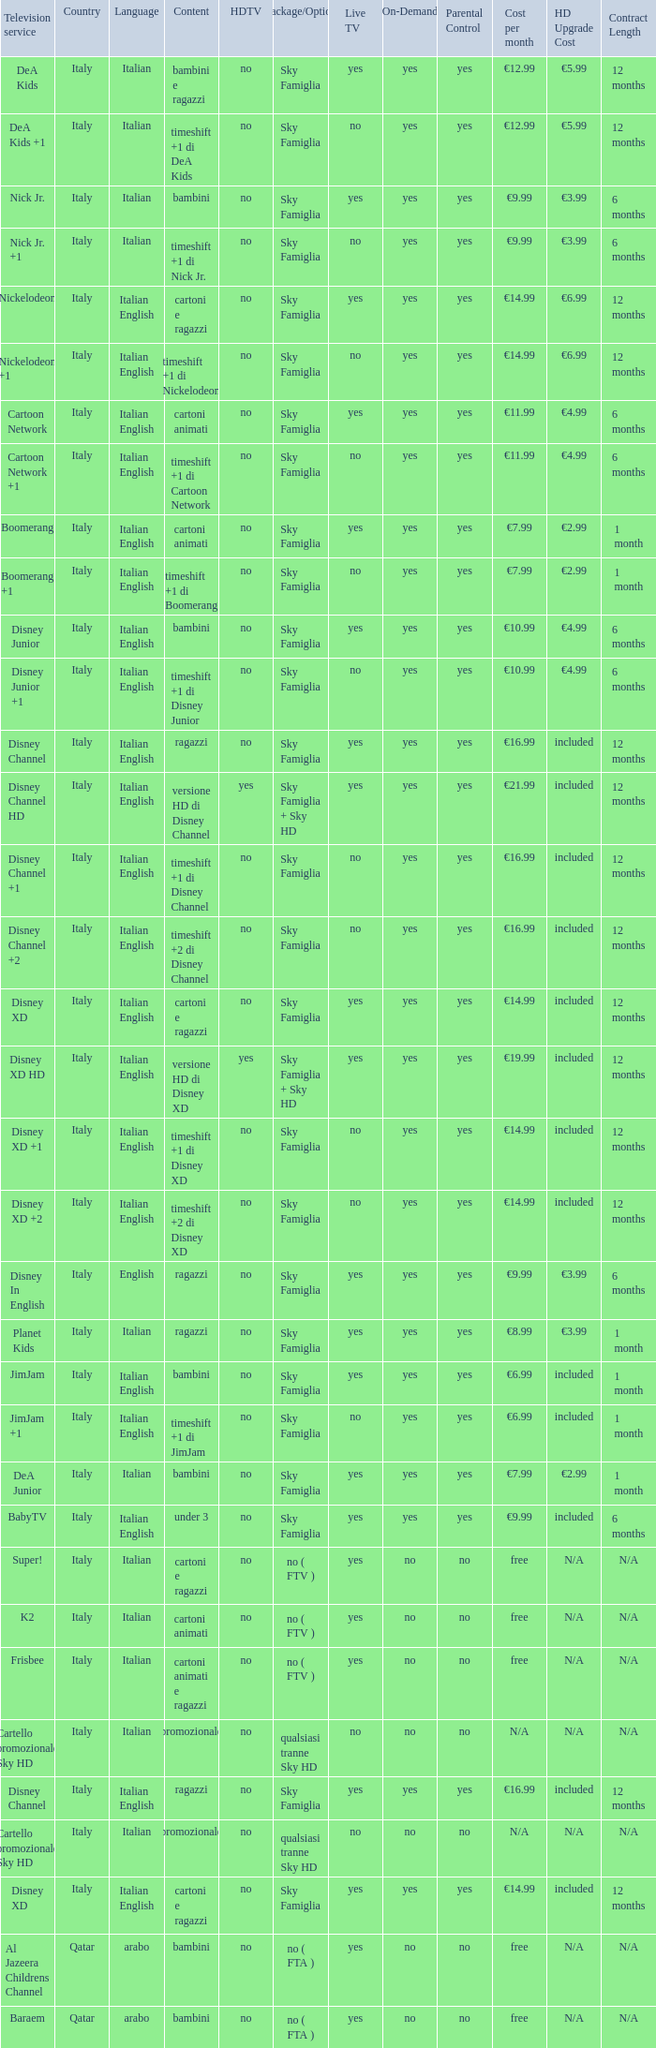What is the Country when the language is italian english, and the television service is disney xd +1? Italy. 